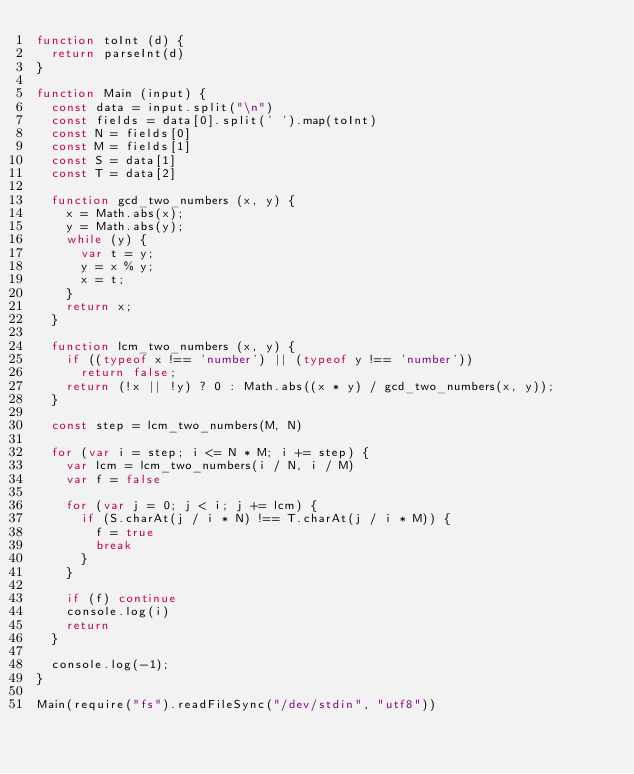Convert code to text. <code><loc_0><loc_0><loc_500><loc_500><_JavaScript_>function toInt (d) {
  return parseInt(d)
}

function Main (input) {
  const data = input.split("\n")
  const fields = data[0].split(' ').map(toInt)
  const N = fields[0]
  const M = fields[1]
  const S = data[1]
  const T = data[2]

  function gcd_two_numbers (x, y) {
    x = Math.abs(x);
    y = Math.abs(y);
    while (y) {
      var t = y;
      y = x % y;
      x = t;
    }
    return x;
  }

  function lcm_two_numbers (x, y) {
    if ((typeof x !== 'number') || (typeof y !== 'number'))
      return false;
    return (!x || !y) ? 0 : Math.abs((x * y) / gcd_two_numbers(x, y));
  }

  const step = lcm_two_numbers(M, N)

  for (var i = step; i <= N * M; i += step) {
    var lcm = lcm_two_numbers(i / N, i / M)
    var f = false

    for (var j = 0; j < i; j += lcm) {
      if (S.charAt(j / i * N) !== T.charAt(j / i * M)) {
        f = true
        break
      }
    }

    if (f) continue
    console.log(i)
    return
  }

  console.log(-1);
}

Main(require("fs").readFileSync("/dev/stdin", "utf8"))</code> 